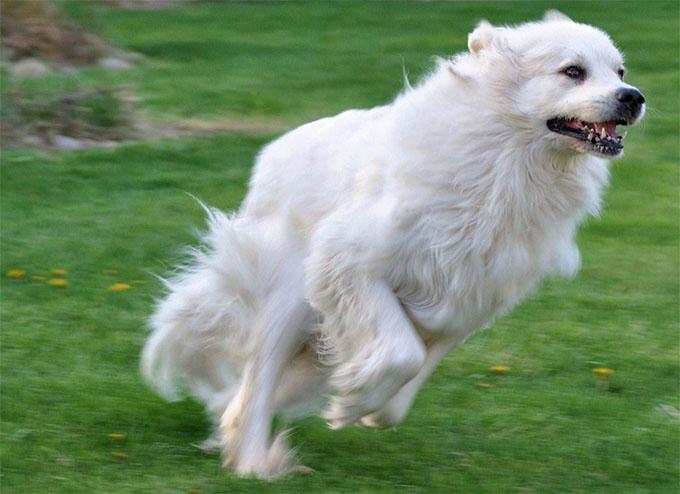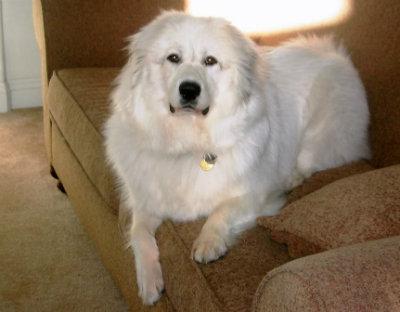The first image is the image on the left, the second image is the image on the right. Assess this claim about the two images: "A dog is lying on all fours with its head up in the air.". Correct or not? Answer yes or no. Yes. The first image is the image on the left, the second image is the image on the right. Examine the images to the left and right. Is the description "An image shows a white dog standing still, its body in profile." accurate? Answer yes or no. No. 